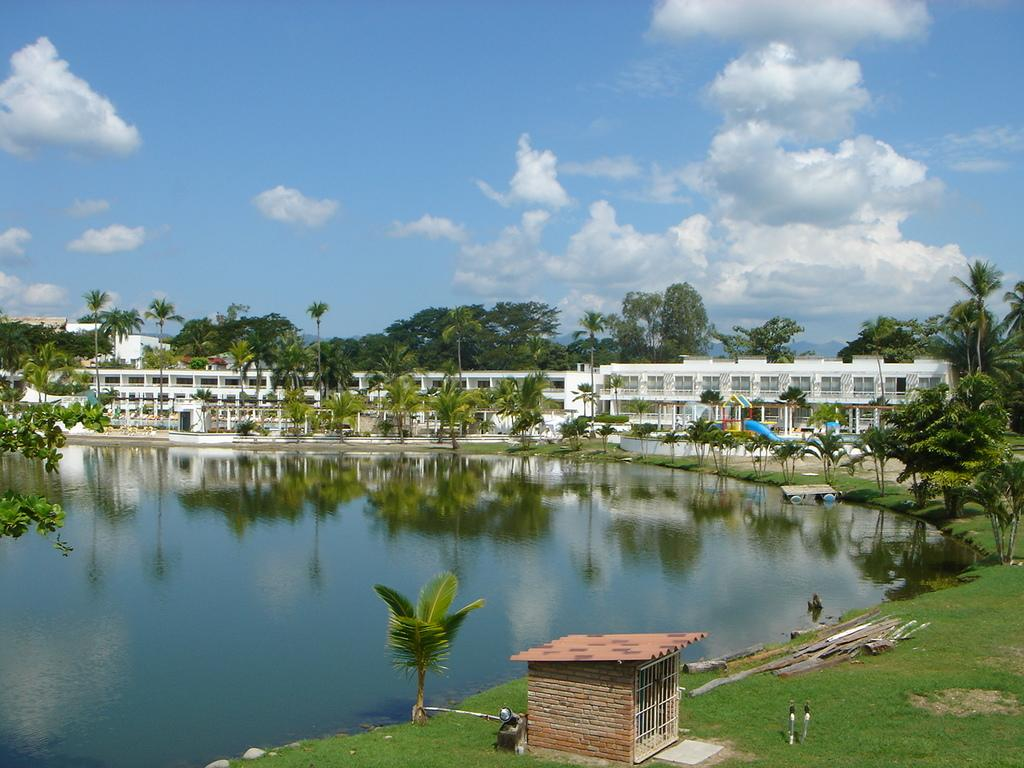What type of natural environment is visible in the image? There is grass and trees visible in the image. What can be seen in the water surface in the image? The information provided does not specify any details about the water surface. What type of man-made structures are present in the image? There are buildings visible in the image. Where is the throne located in the image? There is no throne present in the image. Can you tell me how much honey is being stored in the image? There is no honey storage visible in the image. 